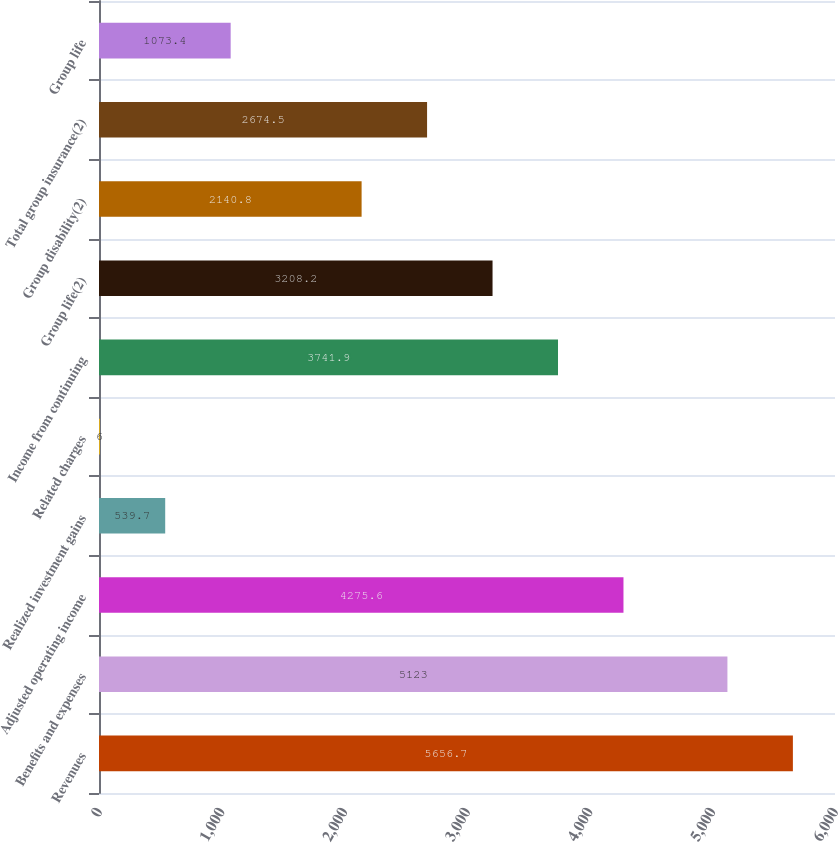<chart> <loc_0><loc_0><loc_500><loc_500><bar_chart><fcel>Revenues<fcel>Benefits and expenses<fcel>Adjusted operating income<fcel>Realized investment gains<fcel>Related charges<fcel>Income from continuing<fcel>Group life(2)<fcel>Group disability(2)<fcel>Total group insurance(2)<fcel>Group life<nl><fcel>5656.7<fcel>5123<fcel>4275.6<fcel>539.7<fcel>6<fcel>3741.9<fcel>3208.2<fcel>2140.8<fcel>2674.5<fcel>1073.4<nl></chart> 